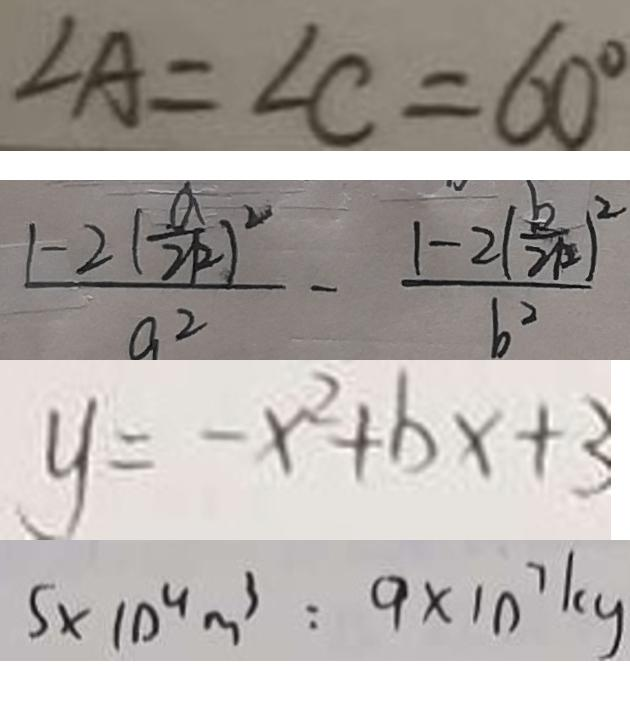Convert formula to latex. <formula><loc_0><loc_0><loc_500><loc_500>\angle A = \angle C = 6 0 ^ { \circ } 
 \frac { 1 - 2 ( \frac { a } { 2 k } ) ^ { 2 } } { a ^ { 2 } } - \frac { 1 - 2 ( \frac { k } { 2 k } ) ^ { 2 } } { b ^ { 2 } } 
 y = - x ^ { 2 } + b x + 3 
 5 \times 1 0 ^ { 4 } m ^ { 3 } : 9 \times 1 0 ^ { 7 } k g</formula> 